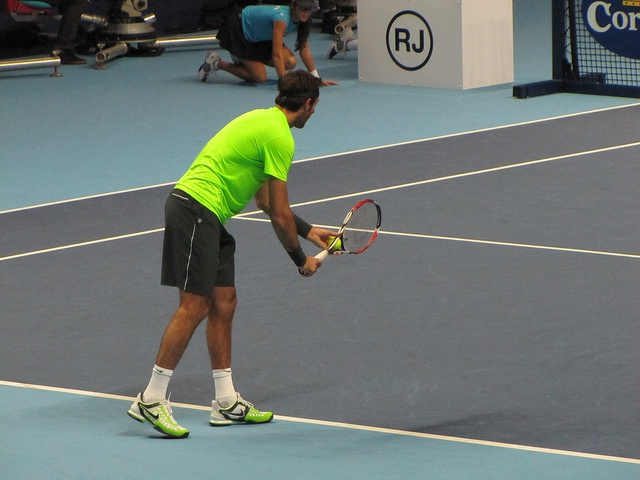Describe the objects in this image and their specific colors. I can see people in black, maroon, and lime tones, people in black, gray, maroon, and darkblue tones, people in black, maroon, and gray tones, tennis racket in black, gray, and khaki tones, and sports ball in black, olive, yellow, and khaki tones in this image. 